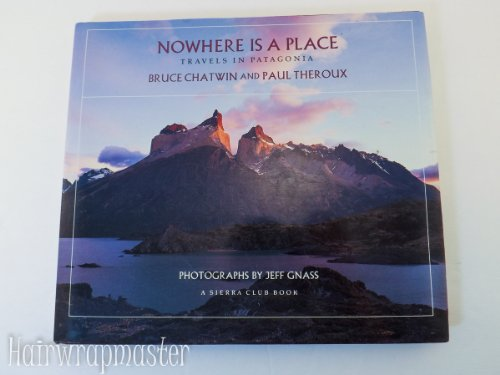Is this book related to Travel? Yes, this book is fundamentally about travel, focusing particularly on explorations and experiences within Patagonia. 